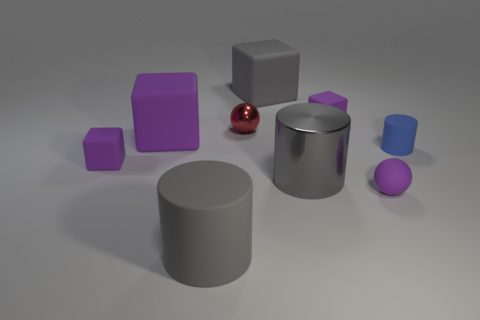Does anything in this image suggest it could be a part of a larger scene or story? While the image presents a simple collection of shapes, one could imagine that it is part of a larger narrative or practical exercise, such as a study in a visual arts class to explore composition, lighting, and color theory. Alternatively, the randomness of the shapes' placement invites viewers to create their own interpretations, possibly seeing it as a still-life setting in an artistic or educational environment. 